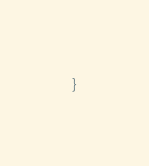Convert code to text. <code><loc_0><loc_0><loc_500><loc_500><_Go_>}
</code> 